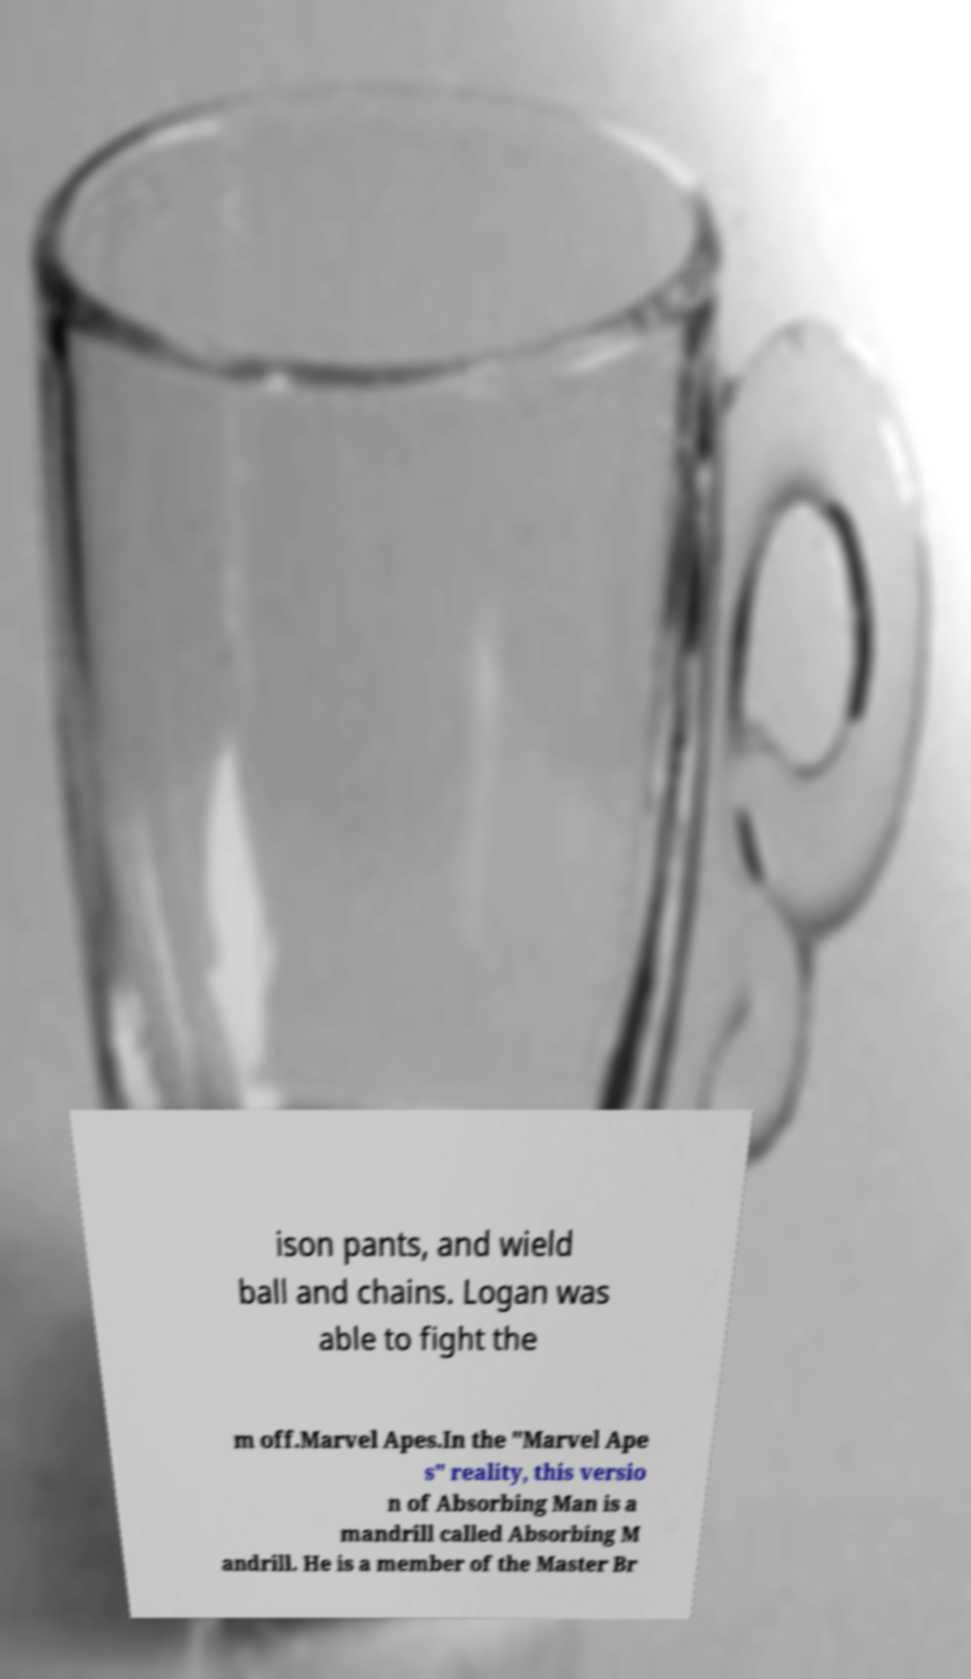Could you extract and type out the text from this image? ison pants, and wield ball and chains. Logan was able to fight the m off.Marvel Apes.In the "Marvel Ape s" reality, this versio n of Absorbing Man is a mandrill called Absorbing M andrill. He is a member of the Master Br 